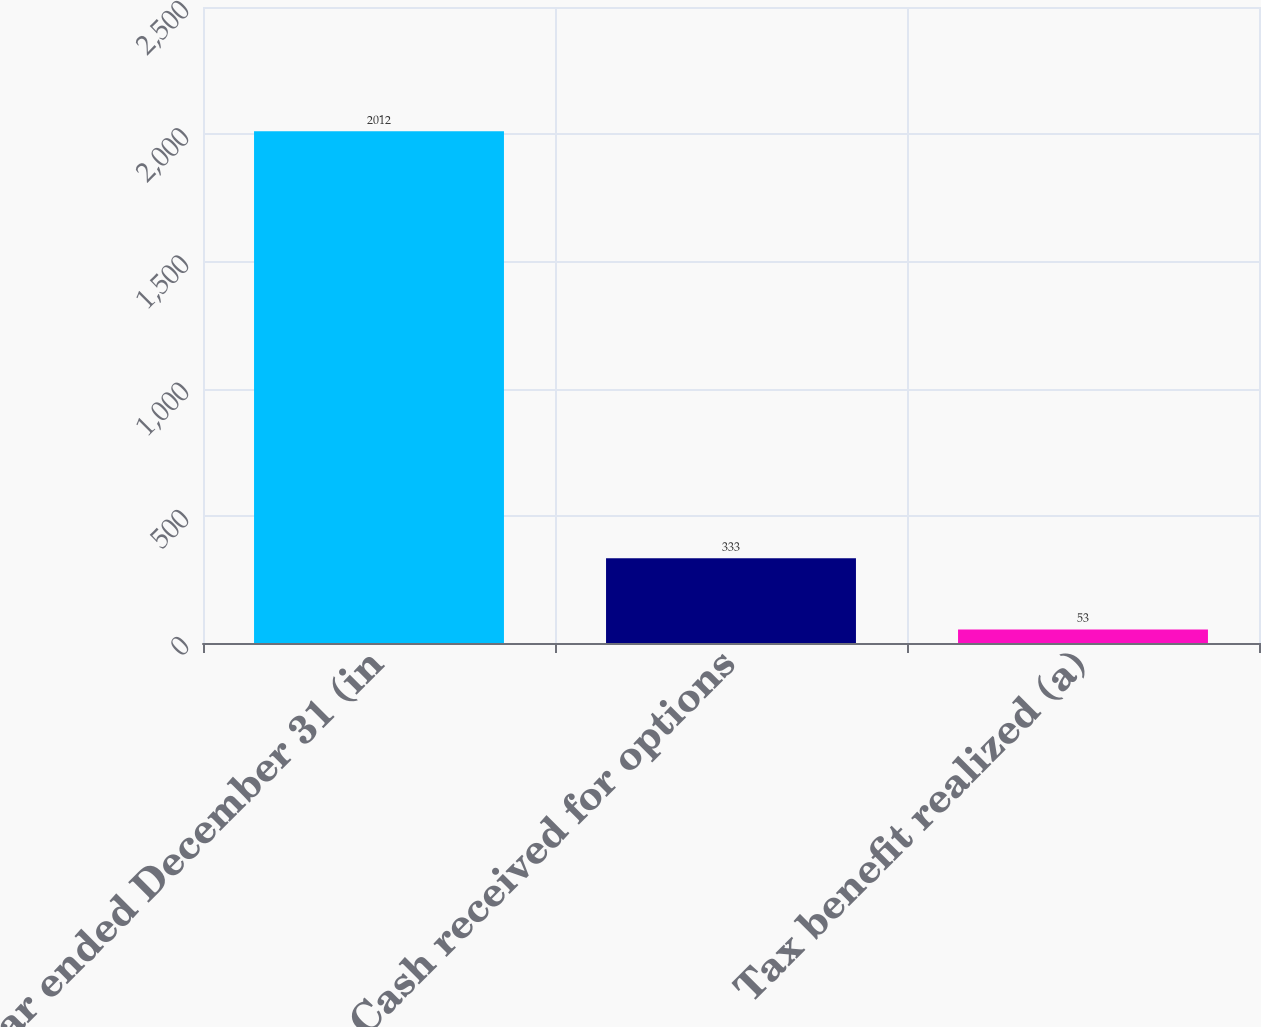<chart> <loc_0><loc_0><loc_500><loc_500><bar_chart><fcel>Year ended December 31 (in<fcel>Cash received for options<fcel>Tax benefit realized (a)<nl><fcel>2012<fcel>333<fcel>53<nl></chart> 